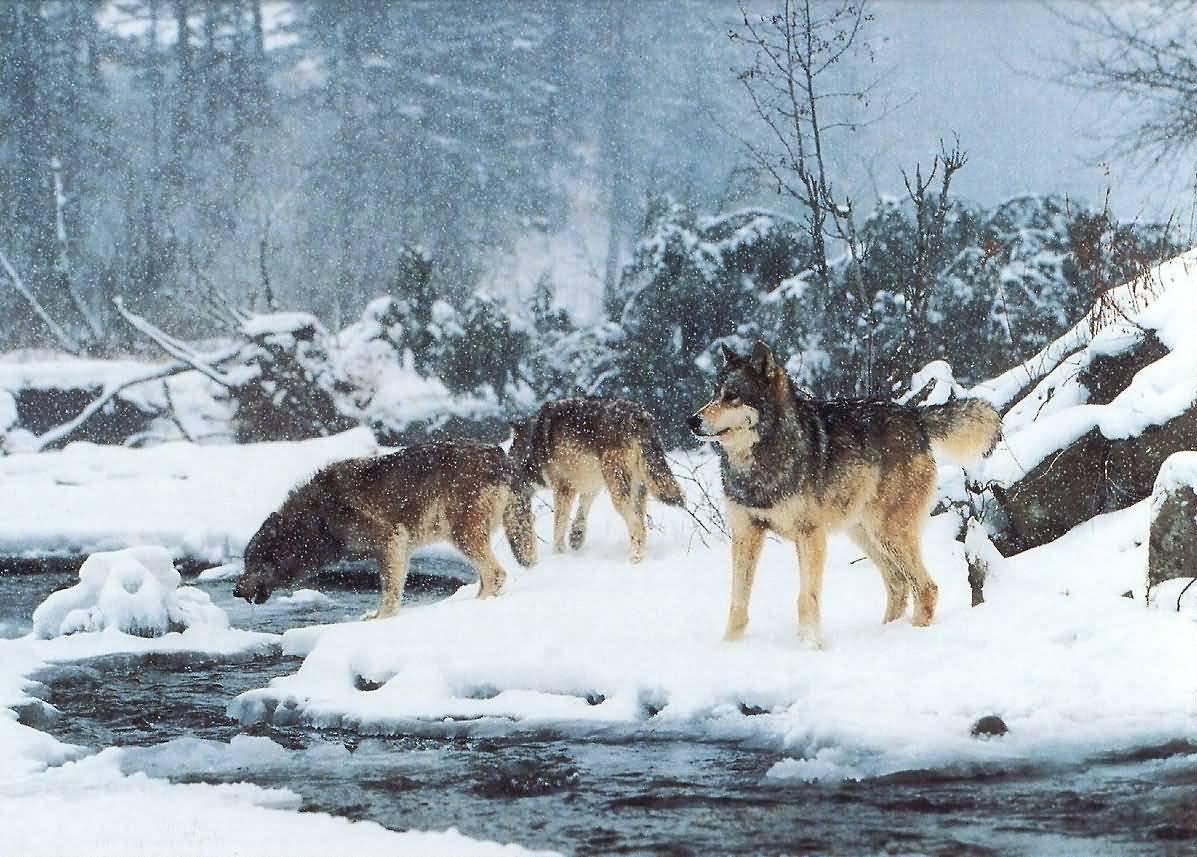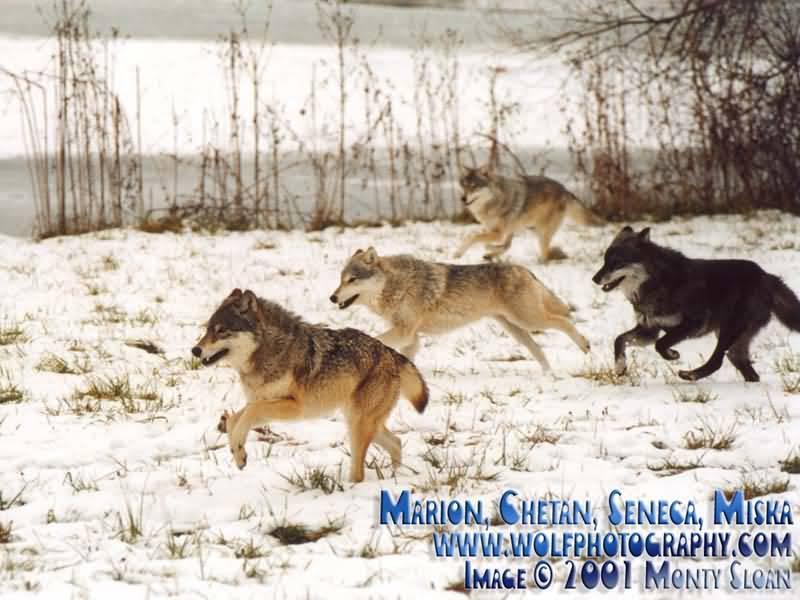The first image is the image on the left, the second image is the image on the right. Considering the images on both sides, is "There are seven wolves in total." valid? Answer yes or no. Yes. The first image is the image on the left, the second image is the image on the right. Considering the images on both sides, is "All images show wolves on snow, and the right image contains more wolves than the left image." valid? Answer yes or no. Yes. 